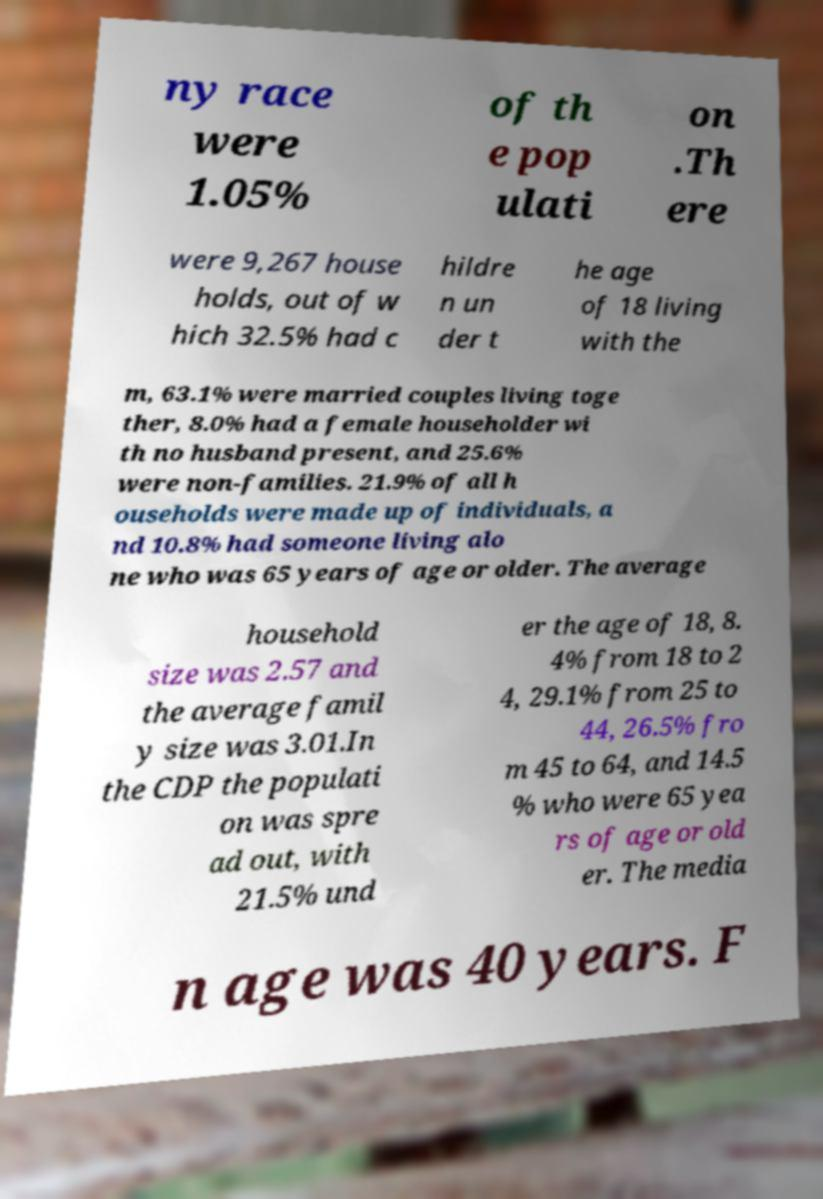I need the written content from this picture converted into text. Can you do that? ny race were 1.05% of th e pop ulati on .Th ere were 9,267 house holds, out of w hich 32.5% had c hildre n un der t he age of 18 living with the m, 63.1% were married couples living toge ther, 8.0% had a female householder wi th no husband present, and 25.6% were non-families. 21.9% of all h ouseholds were made up of individuals, a nd 10.8% had someone living alo ne who was 65 years of age or older. The average household size was 2.57 and the average famil y size was 3.01.In the CDP the populati on was spre ad out, with 21.5% und er the age of 18, 8. 4% from 18 to 2 4, 29.1% from 25 to 44, 26.5% fro m 45 to 64, and 14.5 % who were 65 yea rs of age or old er. The media n age was 40 years. F 